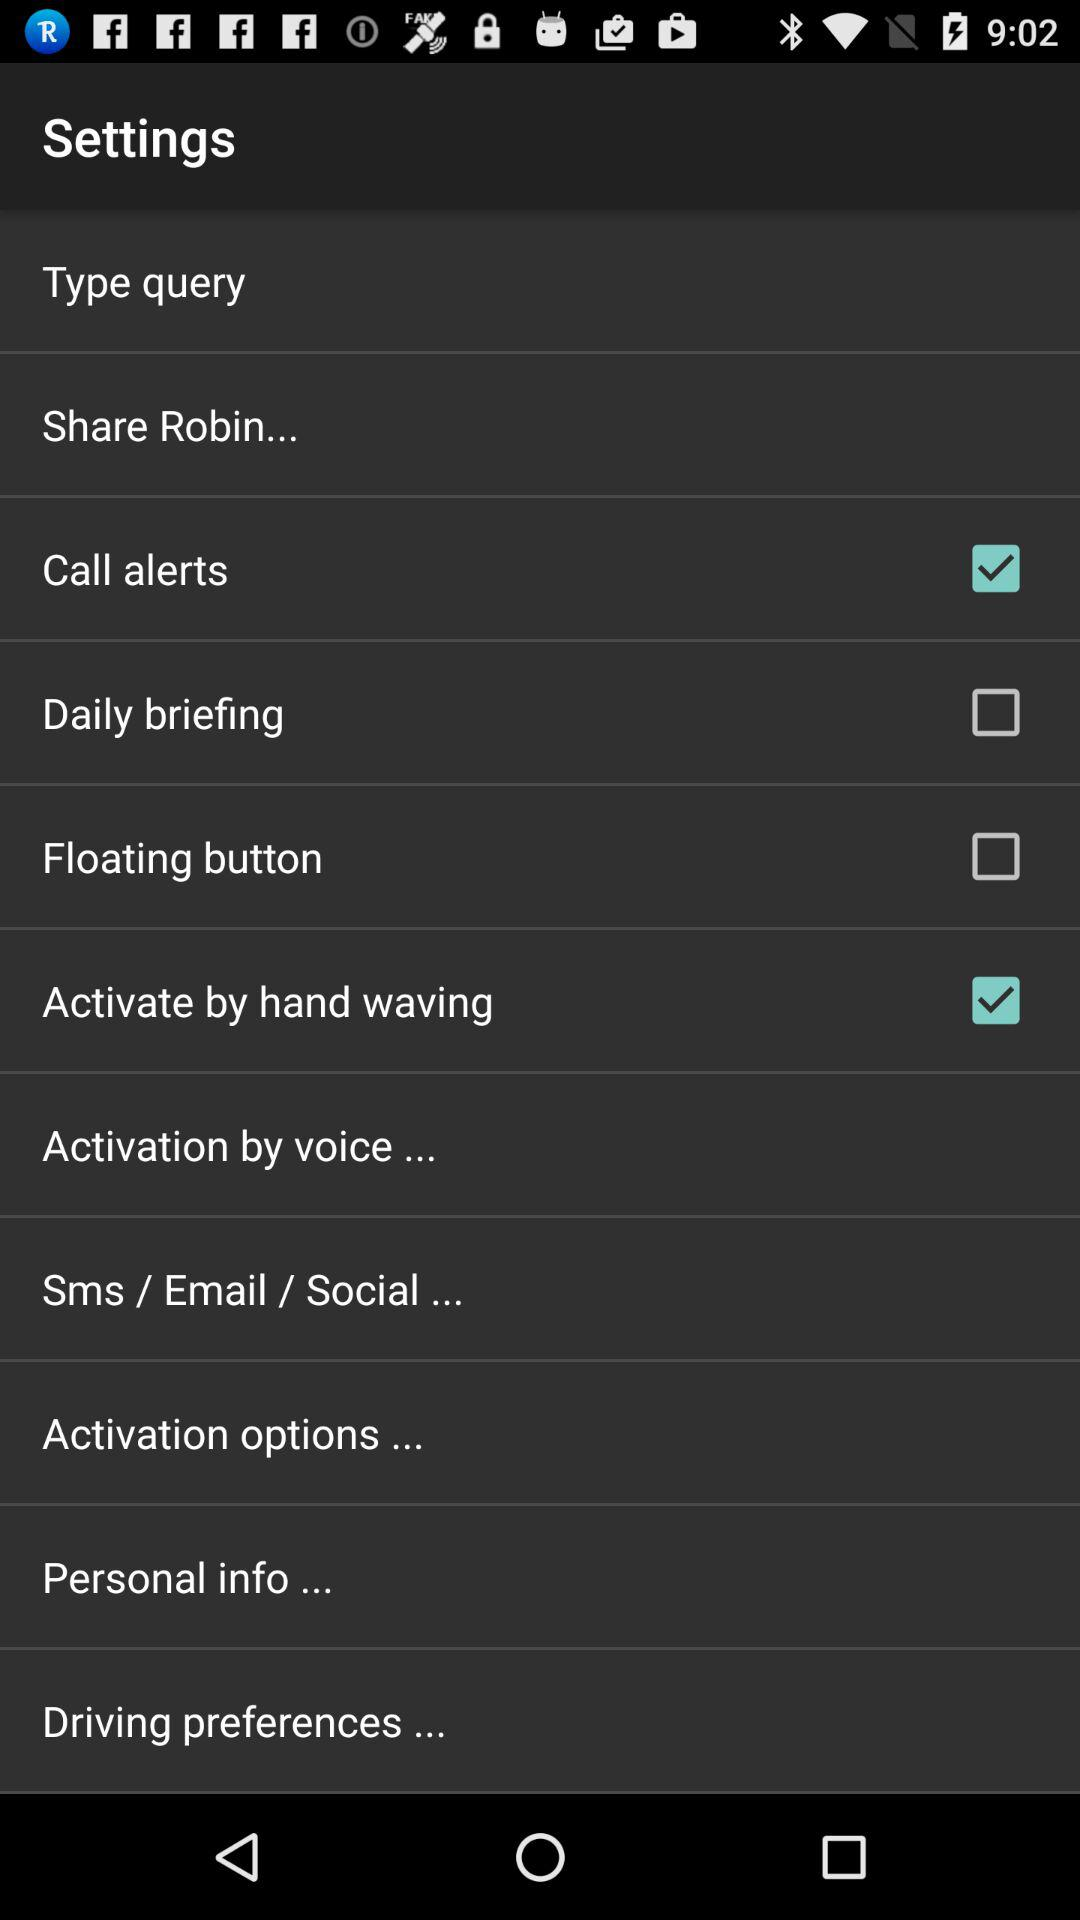Through which applications can this be shared?
When the provided information is insufficient, respond with <no answer>. <no answer> 